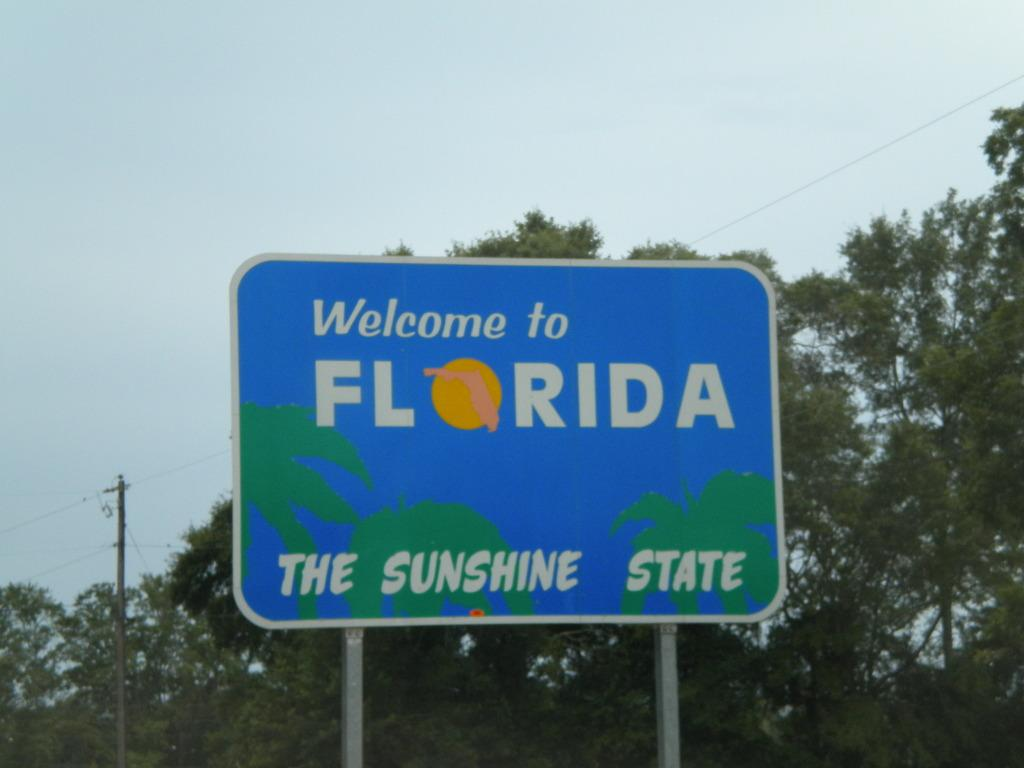<image>
Give a short and clear explanation of the subsequent image. a Welcome to Florida The Sunshine State sign along a road 